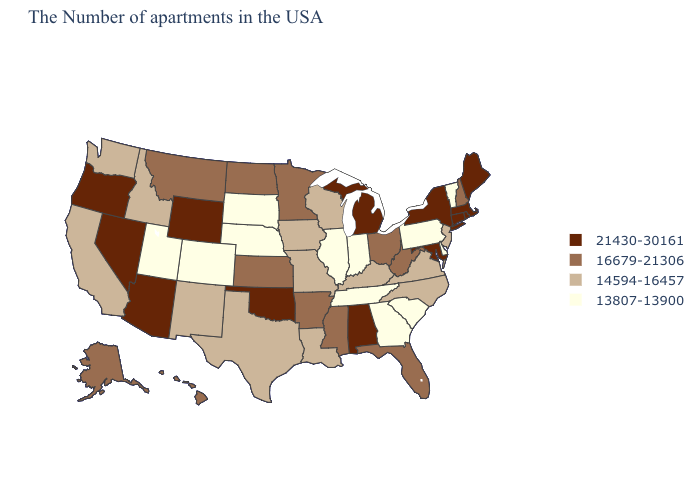Does Nevada have the highest value in the USA?
Be succinct. Yes. Among the states that border Kentucky , which have the highest value?
Answer briefly. West Virginia, Ohio. What is the value of Hawaii?
Short answer required. 16679-21306. Name the states that have a value in the range 21430-30161?
Answer briefly. Maine, Massachusetts, Rhode Island, Connecticut, New York, Maryland, Michigan, Alabama, Oklahoma, Wyoming, Arizona, Nevada, Oregon. Does Rhode Island have a lower value than Washington?
Be succinct. No. Does Utah have the lowest value in the West?
Concise answer only. Yes. Does the map have missing data?
Answer briefly. No. How many symbols are there in the legend?
Quick response, please. 4. Does the map have missing data?
Quick response, please. No. Does the first symbol in the legend represent the smallest category?
Quick response, please. No. Does the map have missing data?
Write a very short answer. No. Which states hav the highest value in the MidWest?
Write a very short answer. Michigan. Does Ohio have a higher value than Colorado?
Keep it brief. Yes. Among the states that border Tennessee , does Kentucky have the lowest value?
Keep it brief. No. Which states have the lowest value in the USA?
Give a very brief answer. Vermont, Delaware, Pennsylvania, South Carolina, Georgia, Indiana, Tennessee, Illinois, Nebraska, South Dakota, Colorado, Utah. 